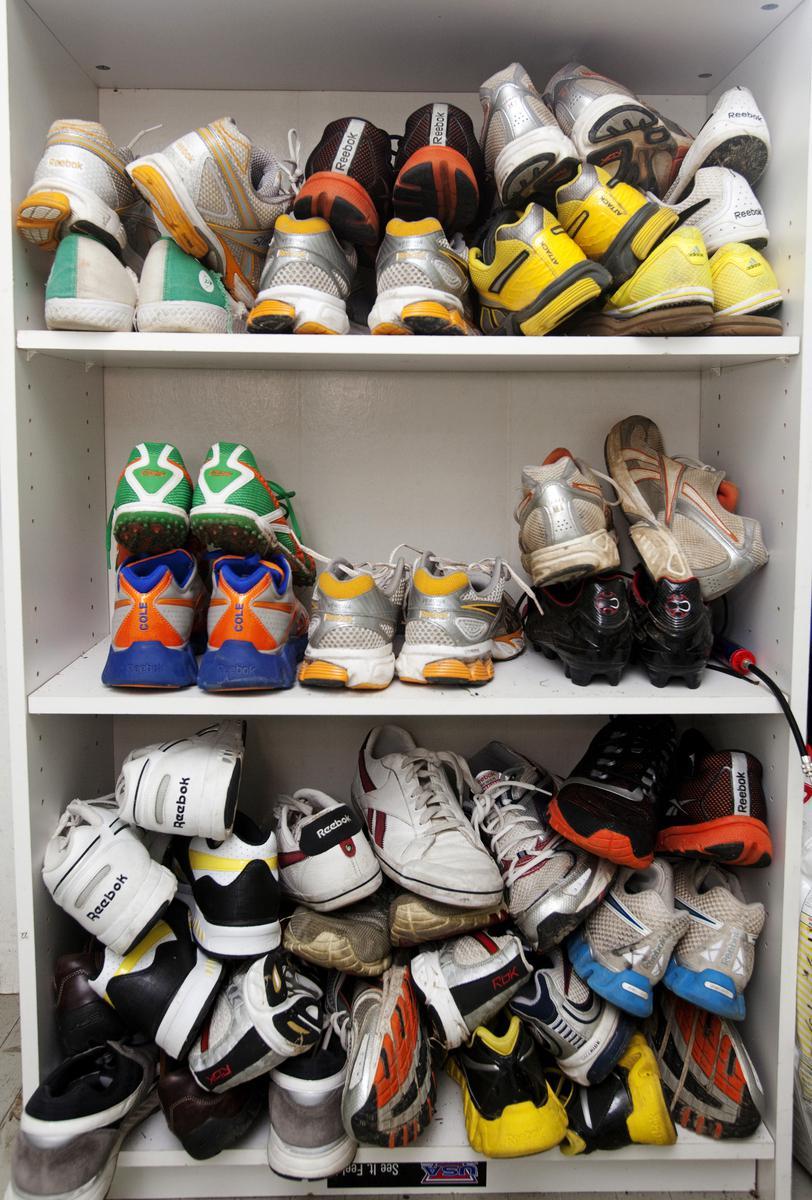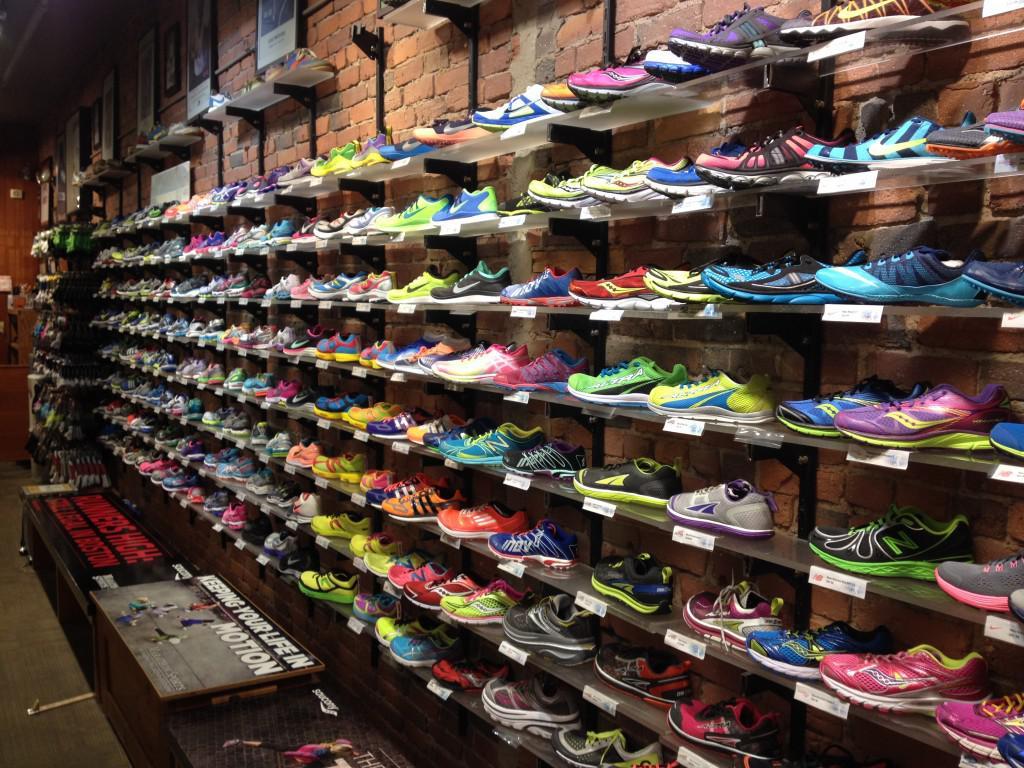The first image is the image on the left, the second image is the image on the right. For the images displayed, is the sentence "Shoes are stacked into cubbies in the image on the left." factually correct? Answer yes or no. Yes. 